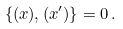<formula> <loc_0><loc_0><loc_500><loc_500>\{ \L ( x ) , \L ( x ^ { \prime } ) \} = 0 \, .</formula> 